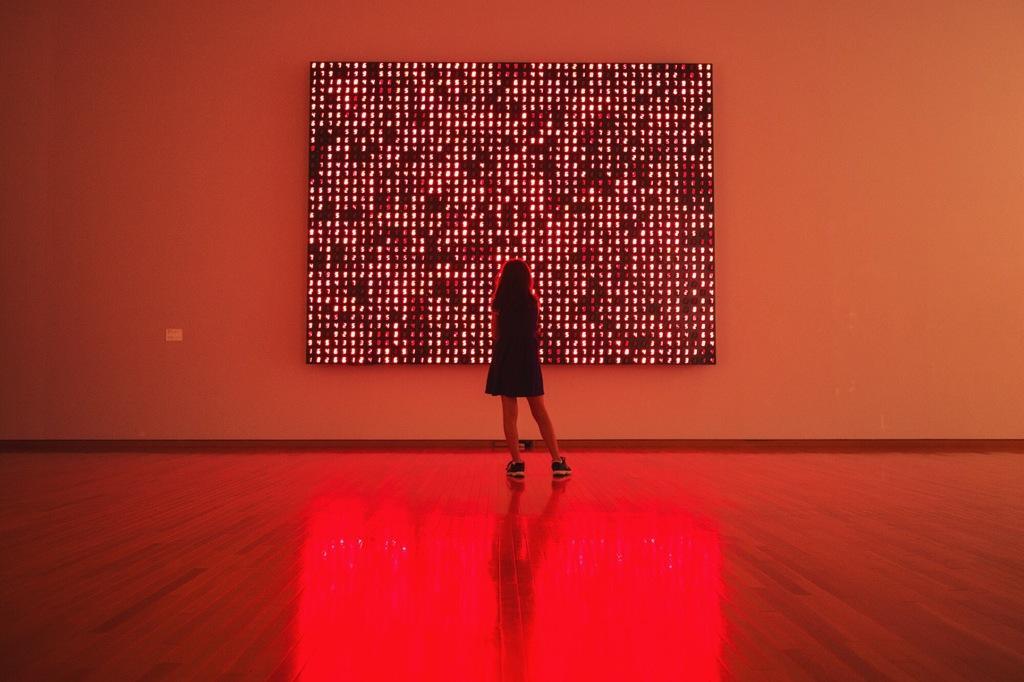In one or two sentences, can you explain what this image depicts? In this image we can see a person. In the background of the image there is a wall and an object. At the bottom of the image there is the floor. 